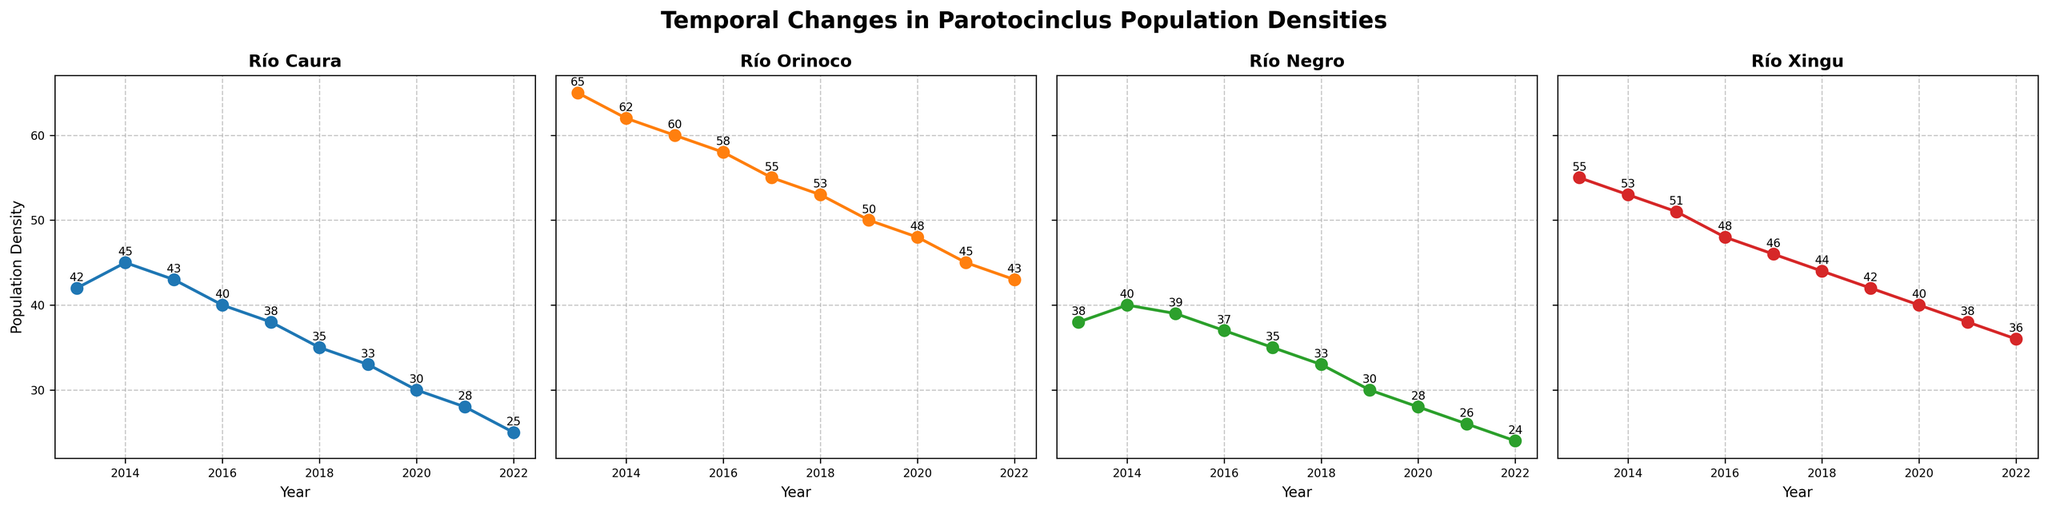Is there a clear decreasing trend in the Parotocinclus population density for the Río Xingu over the past decade? Yes, the population density of Parotocinclus in the Río Xingu decreases gradually from 55 in 2013 to 36 in 2022.
Answer: Yes Which river had the highest Parotocinclus population density in the year 2022? In 2022, the data labels show that Río Orinoco had the highest population density at 43.
Answer: Río Orinoco How does the trend in population density of Parotocinclus in the Río Caura compare to that in the Río Orinoco? Both rivers show a decreasing trend in population density, but the Río Caura has a steeper decline from 42 in 2013 to 25 in 2022, while the Río Orinoco reduces from 65 in 2013 to 43 in 2022.
Answer: Río Caura has a steeper decline Which year saw the sharpest decline in Parotocinclus population in the Río Xingu? By looking at the differences per year, the sharpest decline is between 2014 (53) and 2015 (51), a decrease of 2.
Answer: 2015 What was the population density of Parotocinclus in the Río Negro and Río Orinoco in 2017? The labels indicate that in 2017, Río Negro had a density of 35 and Río Orinoco had a density of 55.
Answer: Río Negro: 35, Río Orinoco: 55 Between which years did the Río Caura see an increase in Parotocinclus population density? The increase in Río Caura's population density occurred between 2013 (42) and 2014 (45).
Answer: 2013-2014 What is the average Parotocinclus population density for Río Negro over the entire period? Summing up the densities for Río Negro (38 + 40 + 39 + 37 + 35 + 33 + 30 + 28 + 26 + 24) which equals 330. Dividing by 10 (years) gives 330/10 = 33.
Answer: 33 In which river did the Parotocinclus populations decrease by exactly 10 over the decade? By observing the end points, Río Negro's population decreased from 38 to 24, a decrease of (38 - 24) = 14 and Río Xingu's population decreased from 55 to 36, a decrease of (55 - 35) = 19. The Río Caura's population decreased from 42 to 25, a decrease of 17, and Río Orinoco decreased by 22. None of them show a population decrease of exactly 10.
Answer: None 